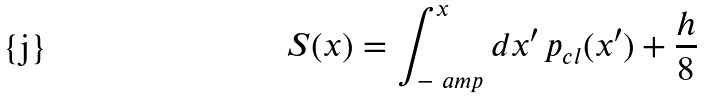Convert formula to latex. <formula><loc_0><loc_0><loc_500><loc_500>S ( x ) = \int _ { - \ a m p } ^ { x } d x ^ { \prime } \, p _ { c l } ( x ^ { \prime } ) + \frac { h } { 8 }</formula> 